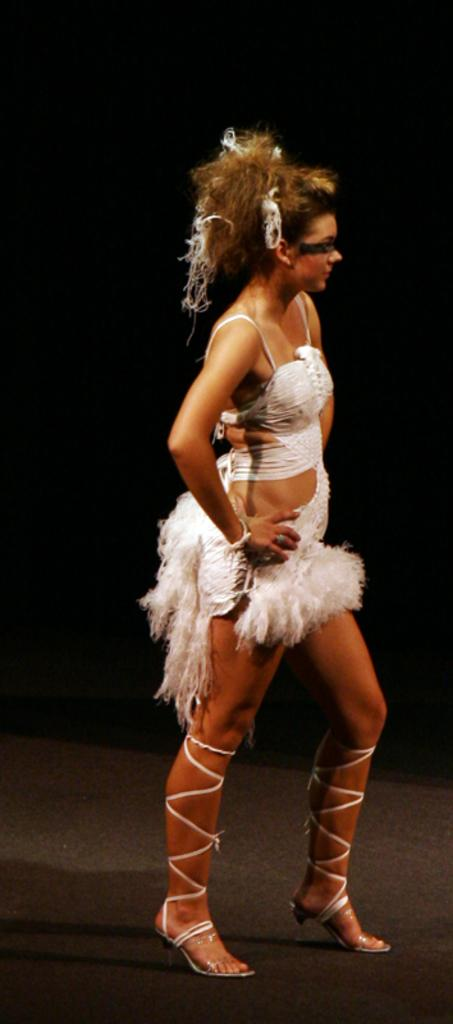Who is the main subject in the image? There is a lady in the image. What is the lady wearing? The lady is wearing a white costume. What can be seen below the lady in the image? The ground is visible in the image. What is the color of the background in the image? The background of the image is dark. What type of snake can be seen slithering in the image? There is no snake present in the image. What is the lady's relation to the person taking the picture? The provided facts do not mention any relation between the lady and the person taking the picture. 